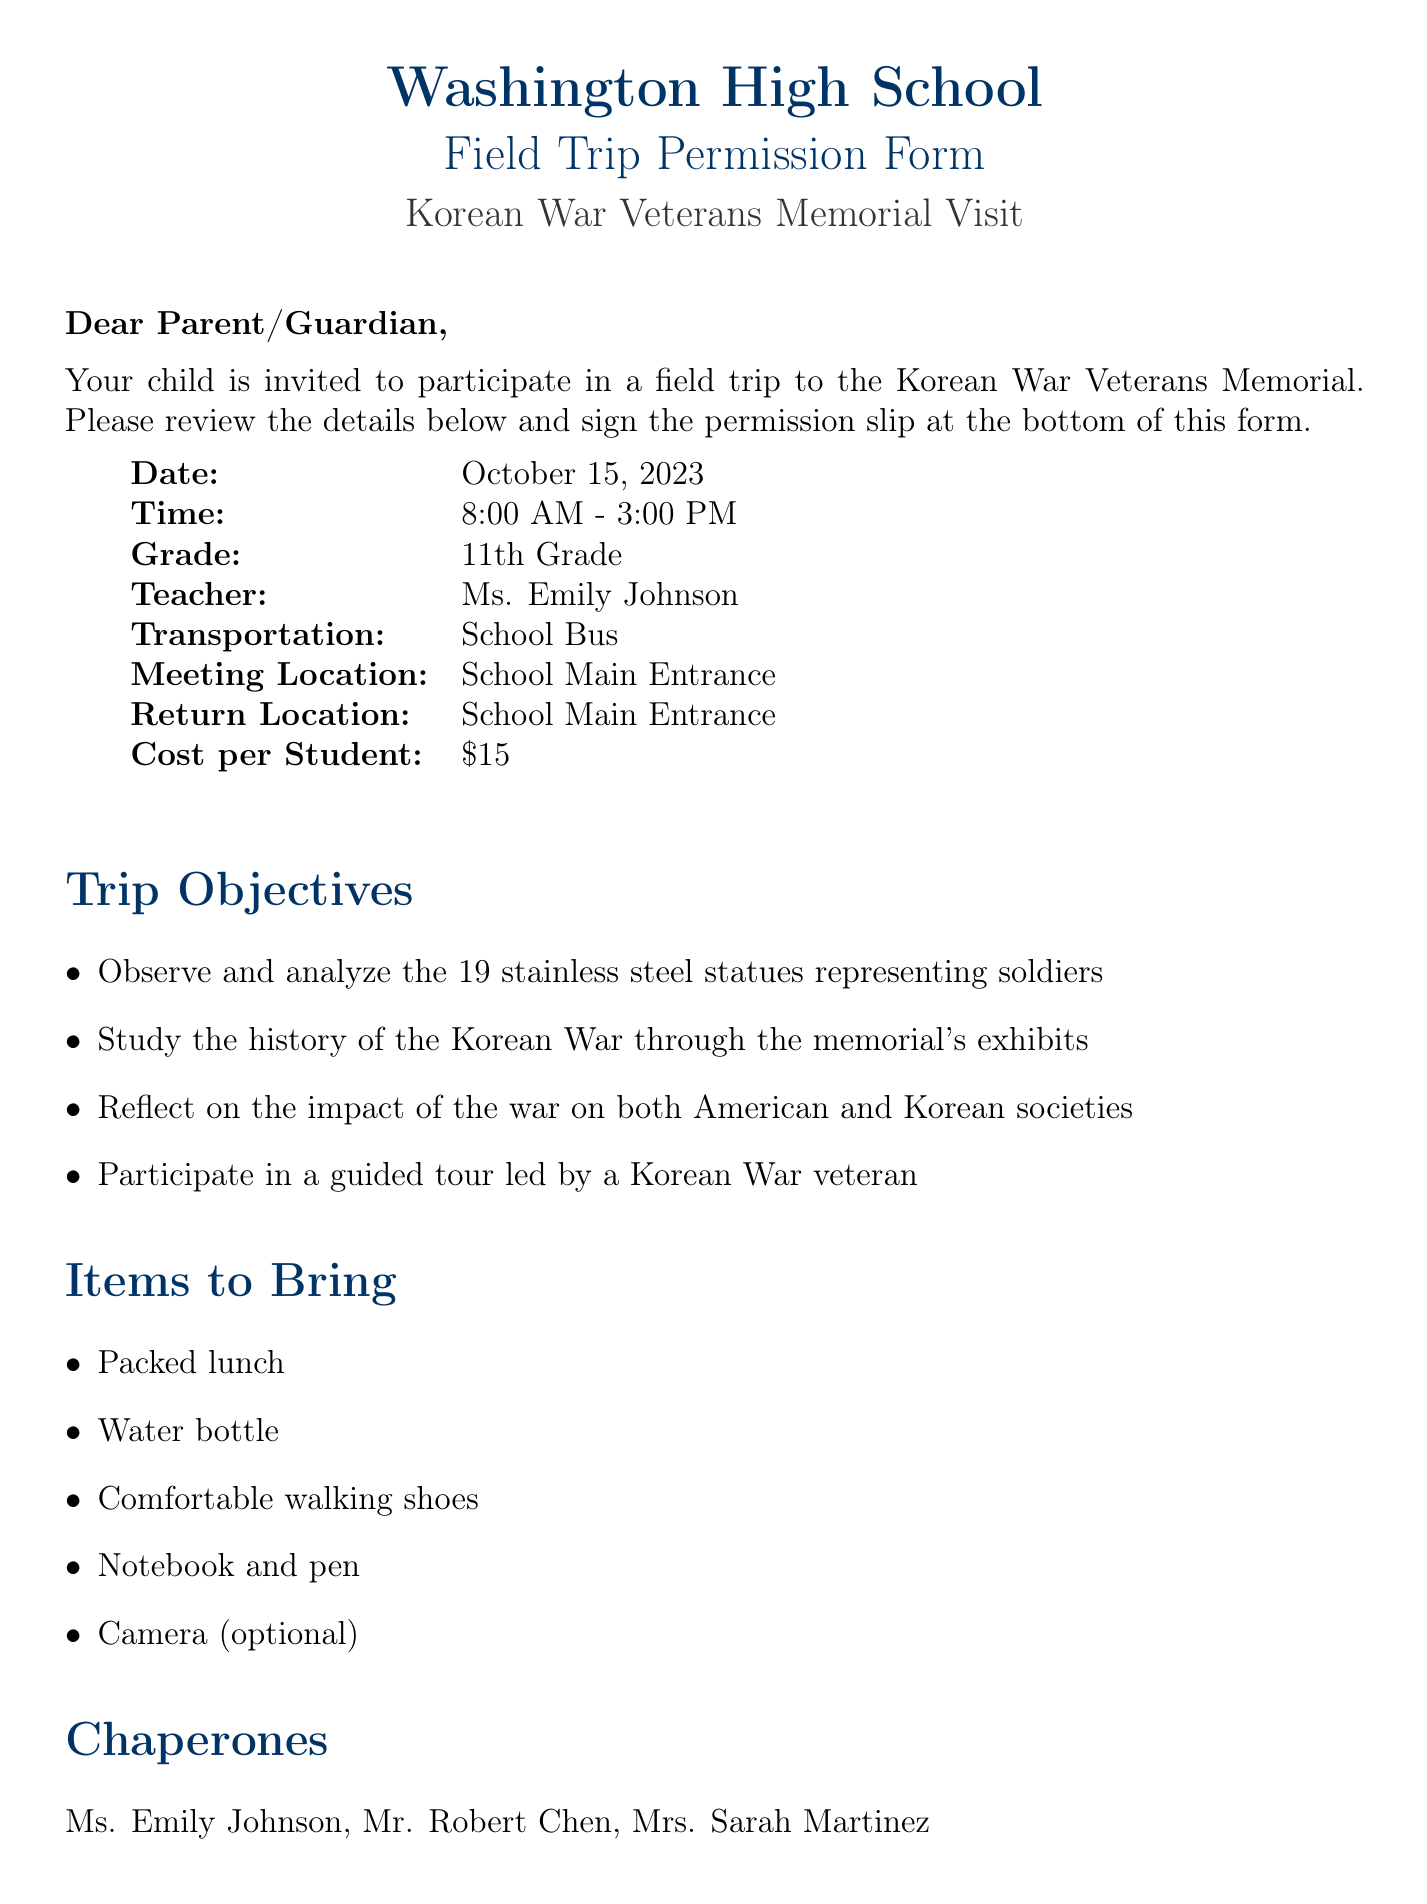what is the name of the teacher? The name of the teacher is explicitly mentioned in the document as Ms. Emily Johnson.
Answer: Ms. Emily Johnson what is the trip date? The trip date is stated clearly in the document, indicating when the field trip will occur.
Answer: October 15, 2023 what is the cost per student? The cost per student is listed in the document, representing the fee required for participation in the trip.
Answer: $15 who are the chaperones for the trip? The document lists the names of the chaperones, providing information about adult supervision during the trip.
Answer: Ms. Emily Johnson, Mr. Robert Chen, Mrs. Sarah Martinez what is the meeting location for the trip? The document specifies the meeting location, indicating where students should gather before departure.
Answer: School Main Entrance what is one item students are advised to bring? The document mentions several items, and this question seeks an example of what students should pack for the trip.
Answer: Packed lunch how long is the trip planned to last? The document specifies the trip time range, providing an understanding of the duration of the outing.
Answer: 7 hours what should a parent indicate regarding medical considerations? The document addresses medical considerations by instructing parents to provide specific information about their child.
Answer: Any medical conditions or allergies who is the emergency contact? The document specifies an emergency contact person and their respective phone number for urgent situations.
Answer: Vice Principal David Thompson 